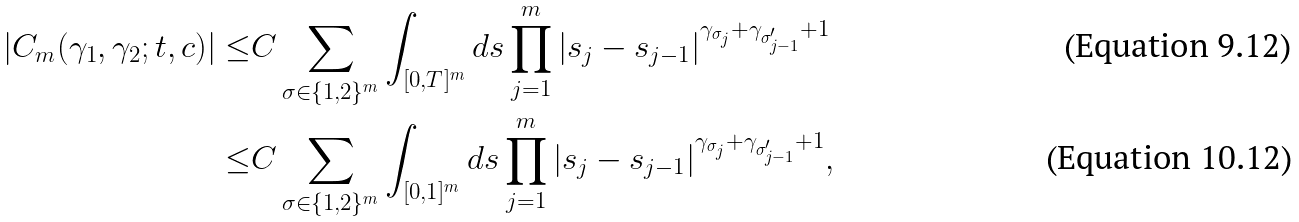<formula> <loc_0><loc_0><loc_500><loc_500>| C _ { m } ( \gamma _ { 1 } , \gamma _ { 2 } ; t , c ) | \leq & C \sum _ { \sigma \in \{ 1 , 2 \} ^ { m } } \int _ { [ 0 , T ] ^ { m } } d s \prod _ { j = 1 } ^ { m } | s _ { j } - s _ { j - 1 } | ^ { \gamma _ { \sigma _ { j } } + \gamma _ { \sigma _ { j - 1 } ^ { \prime } } + 1 } \\ \leq & C \sum _ { \sigma \in \{ 1 , 2 \} ^ { m } } \int _ { [ 0 , 1 ] ^ { m } } d s \prod _ { j = 1 } ^ { m } | s _ { j } - s _ { j - 1 } | ^ { \gamma _ { \sigma _ { j } } + \gamma _ { \sigma _ { j - 1 } ^ { \prime } } + 1 } ,</formula> 